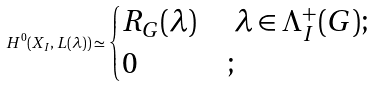Convert formula to latex. <formula><loc_0><loc_0><loc_500><loc_500>H ^ { 0 } ( X _ { I } , L ( \lambda ) ) \simeq \begin{cases} R _ { G } ( \lambda ) & \ \lambda \in \Lambda ^ { + } _ { I } ( G ) ; \\ 0 & ; \end{cases}</formula> 